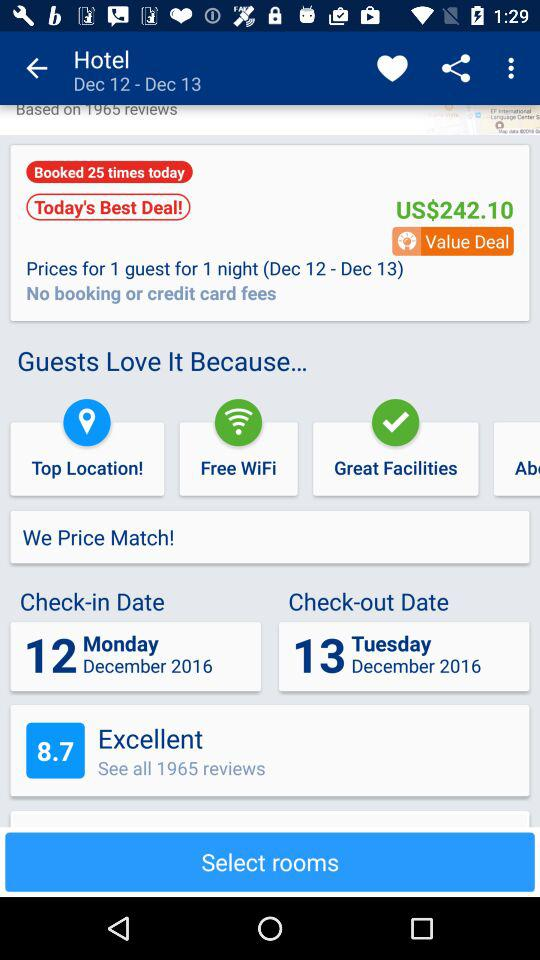How many days does the user stay?
Answer the question using a single word or phrase. 1 